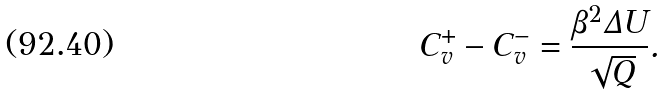Convert formula to latex. <formula><loc_0><loc_0><loc_500><loc_500>C _ { v } ^ { + } - C _ { v } ^ { - } = \frac { \beta ^ { 2 } \Delta U } { \sqrt { Q } } .</formula> 